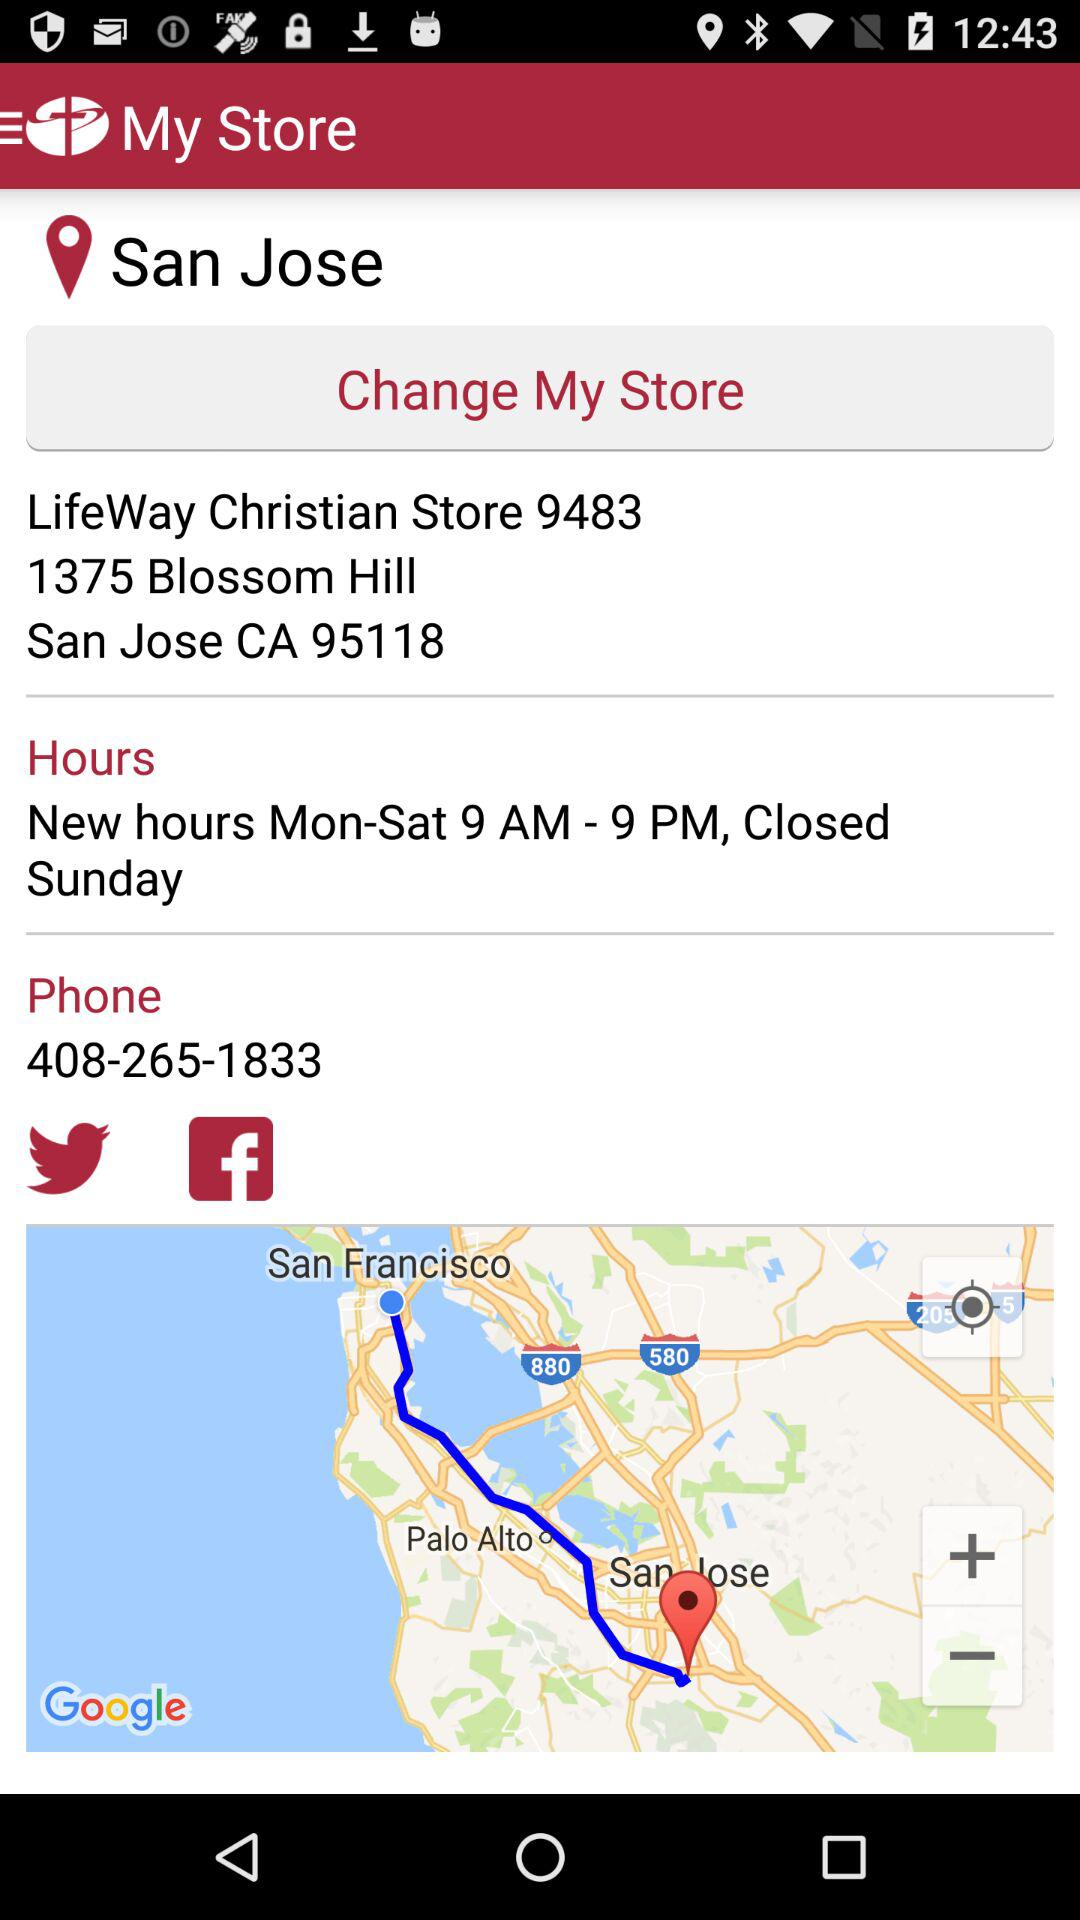What is the name of the application? The name of the application is "My Store". 